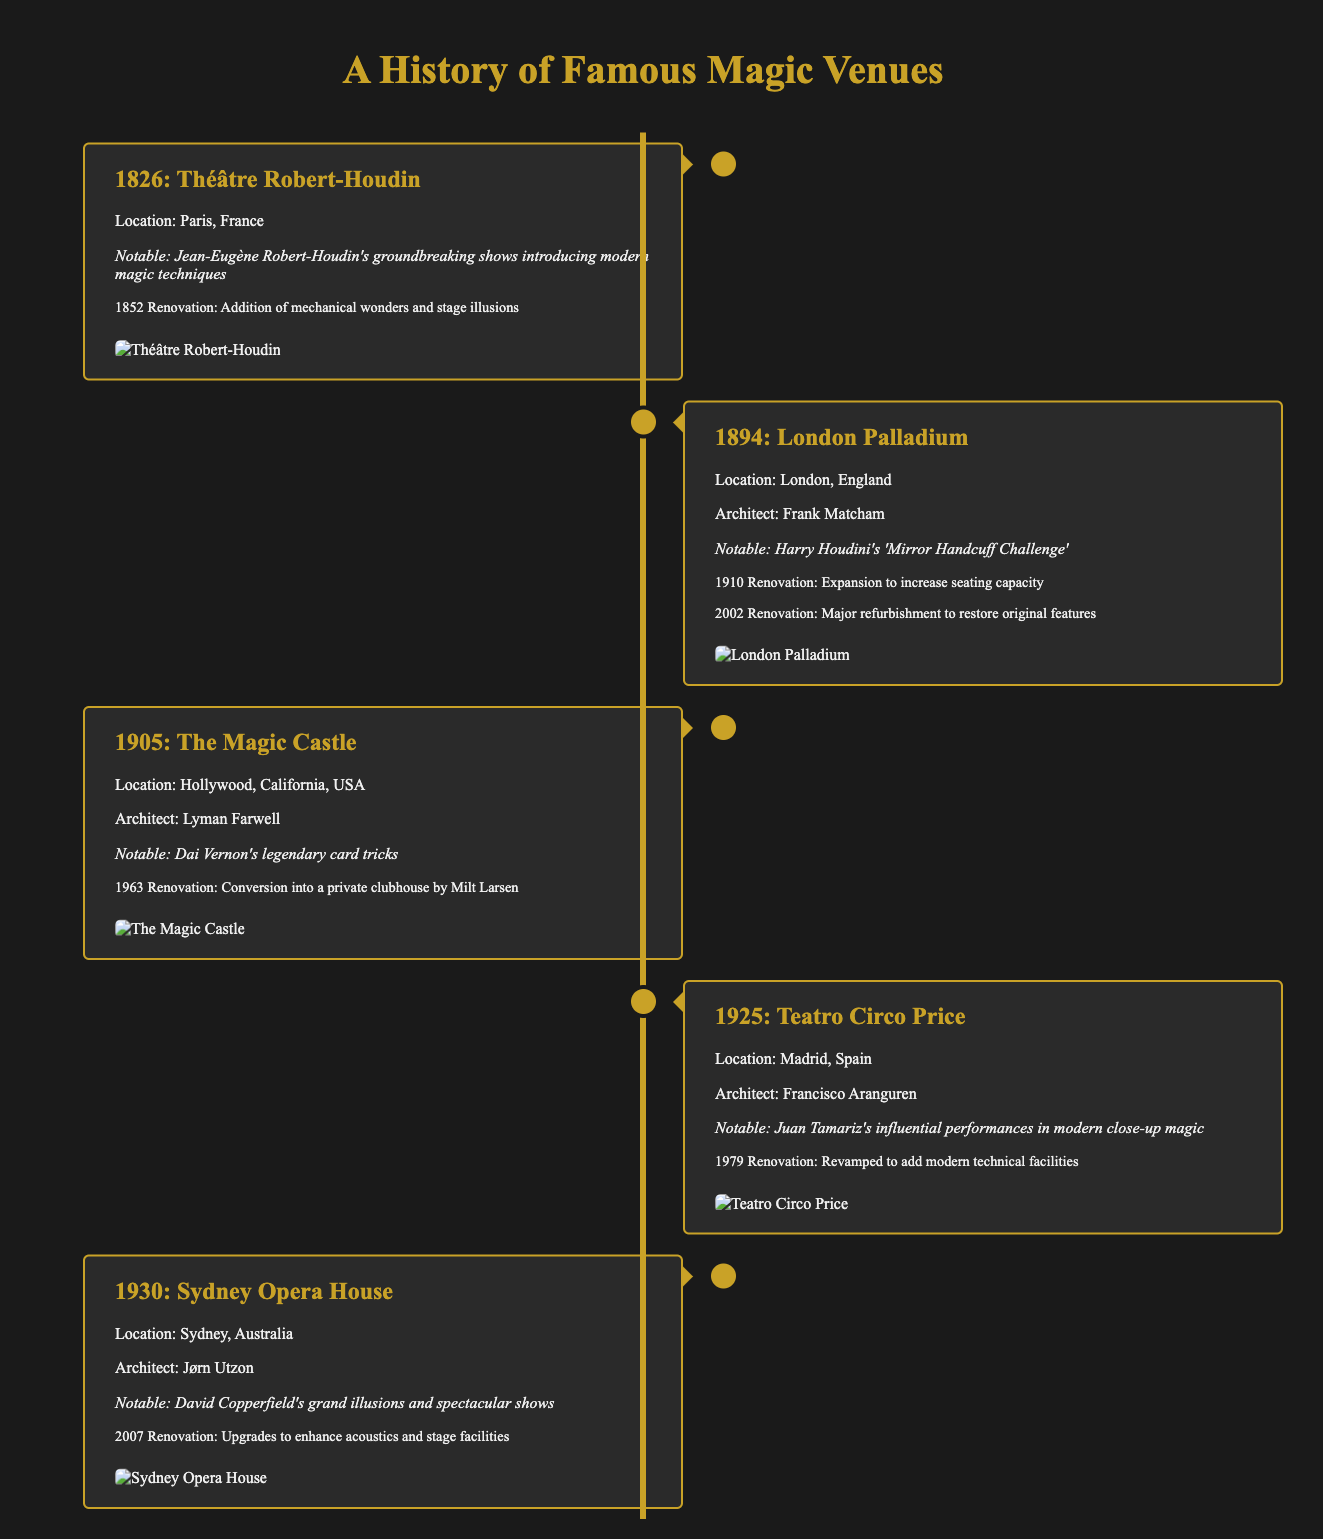what year did the Théâtre Robert-Houdin open? The opening year of the Théâtre Robert-Houdin is stated in the timeline as 1826.
Answer: 1826 who performed the 'Mirror Handcuff Challenge'? The notable performance at the London Palladium is attributed to Harry Houdini.
Answer: Harry Houdini what significant event took place at The Magic Castle in 1963? The 1963 renovation at The Magic Castle involved its conversion into a private clubhouse.
Answer: Conversion into a private clubhouse which venue had performances by Juan Tamariz? The venue that featured Juan Tamariz's influential performances is Teatro Circo Price.
Answer: Teatro Circo Price how many renovations are listed for the Sydney Opera House? The timeline indicates that there is one renovation listed for the Sydney Opera House, which occurred in 2007.
Answer: One who was the architect of the Sydney Opera House? The architect for the Sydney Opera House is mentioned in the document as Jørn Utzon.
Answer: Jørn Utzon what was added during the 1979 renovation of Teatro Circo Price? The 1979 renovation of Teatro Circo Price included modern technical facilities.
Answer: Modern technical facilities what type of performances is associated with Jean-Eugène Robert-Houdin? The document describes Jean-Eugène Robert-Houdin's performances as introducing modern magic techniques.
Answer: Modern magic techniques which magic venue is located in Hollywood, California? The Magic Castle is identified as the magic venue located in Hollywood, California.
Answer: The Magic Castle 